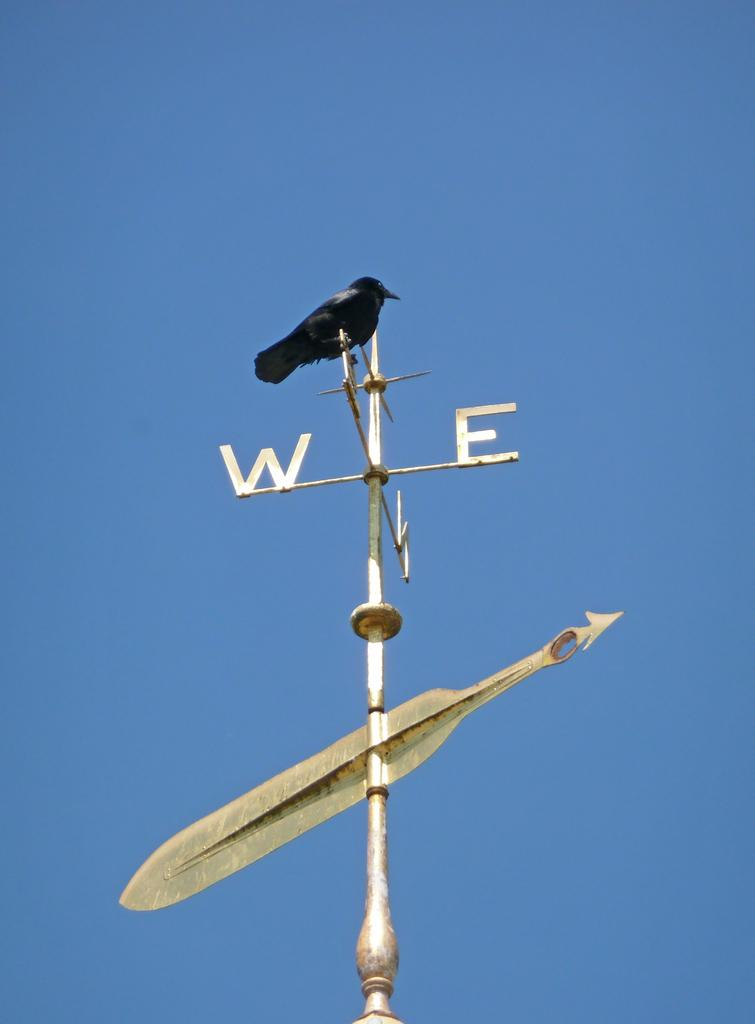What type of animal can be seen in the image? There is a bird in the image. Where is the bird located in the image? The bird is on a direction pole. What can be seen in the background of the image? The sky is visible in the image. What type of tomatoes are being selected in the image? There are no tomatoes present in the image; it features a bird on a direction pole with the sky visible in the background. 